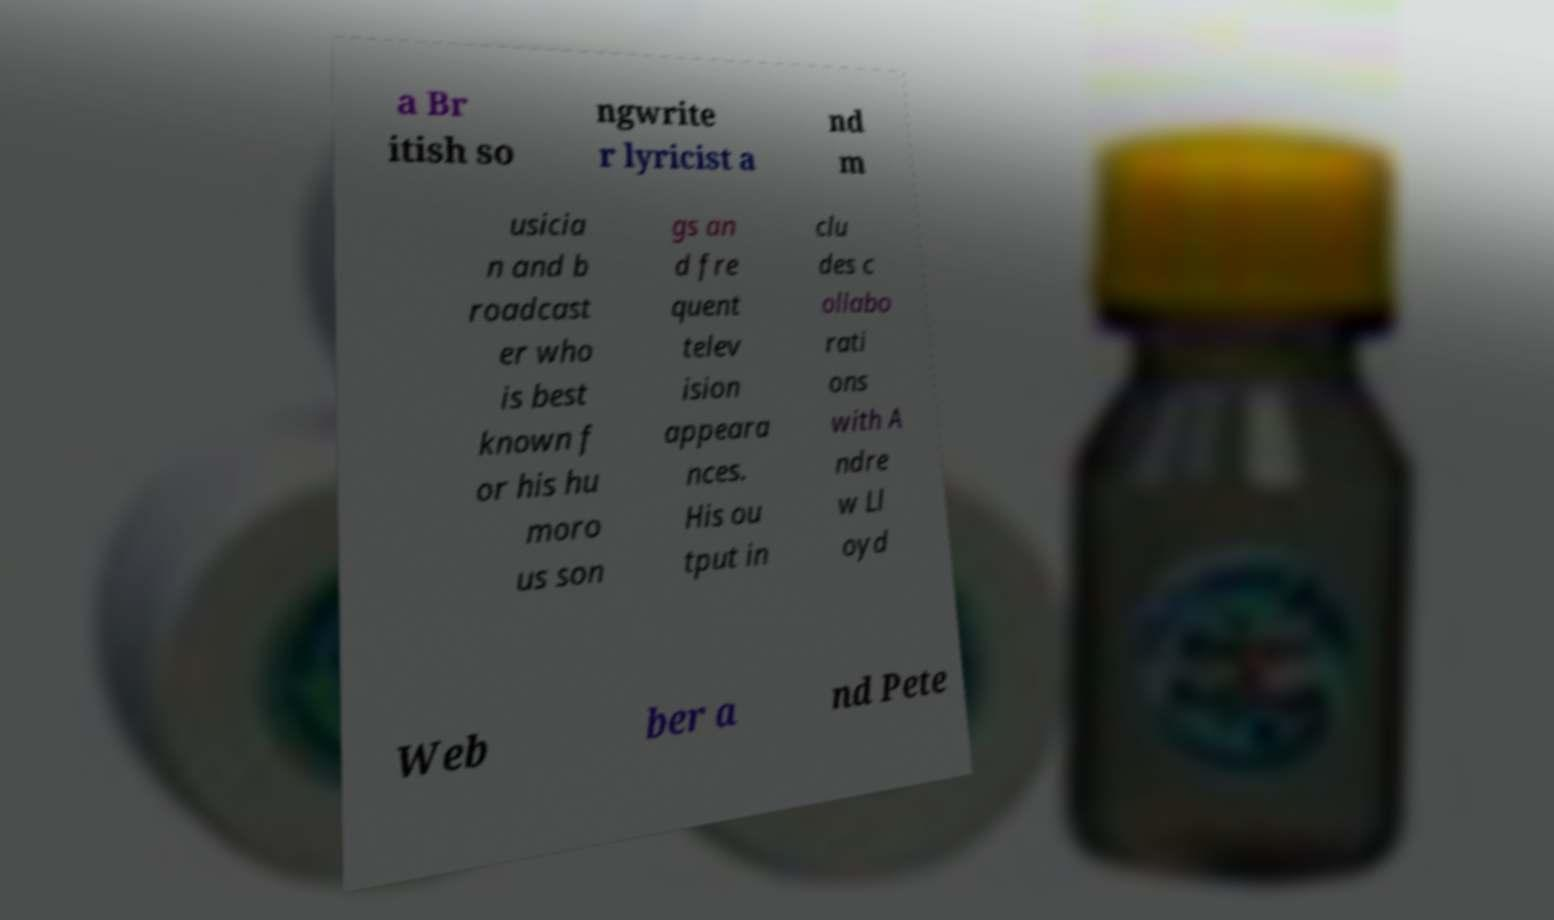There's text embedded in this image that I need extracted. Can you transcribe it verbatim? a Br itish so ngwrite r lyricist a nd m usicia n and b roadcast er who is best known f or his hu moro us son gs an d fre quent telev ision appeara nces. His ou tput in clu des c ollabo rati ons with A ndre w Ll oyd Web ber a nd Pete 